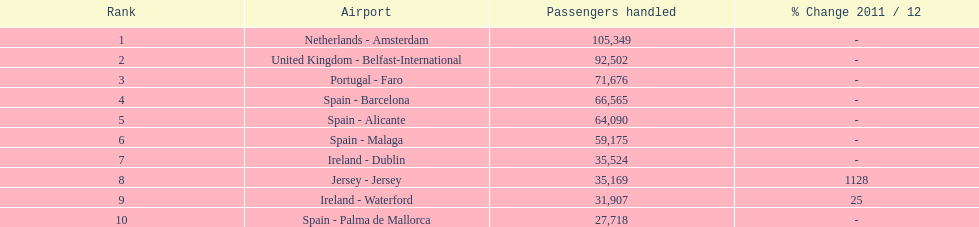How many people are traveling to or from spain? 217,548. 